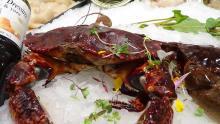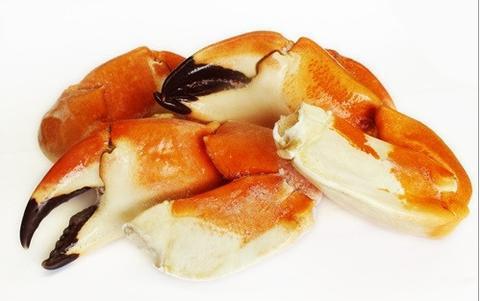The first image is the image on the left, the second image is the image on the right. Given the left and right images, does the statement "There are two whole crabs." hold true? Answer yes or no. No. 